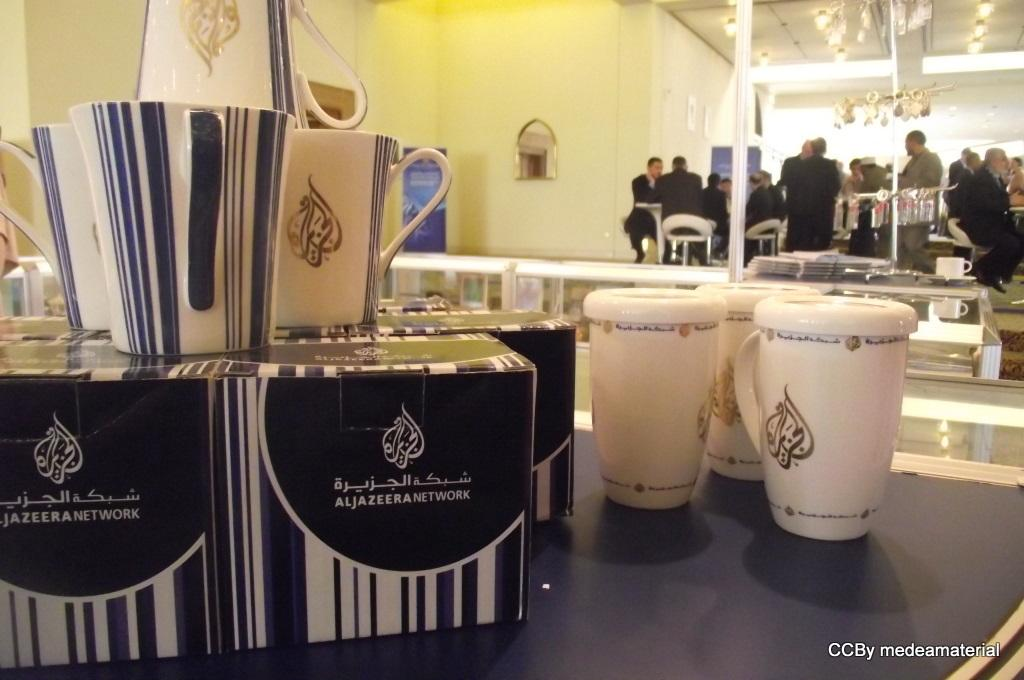<image>
Create a compact narrative representing the image presented. Several coffee mugs sitting next to a stack of boxes that correspond to them with the same aljazeera network brand. 